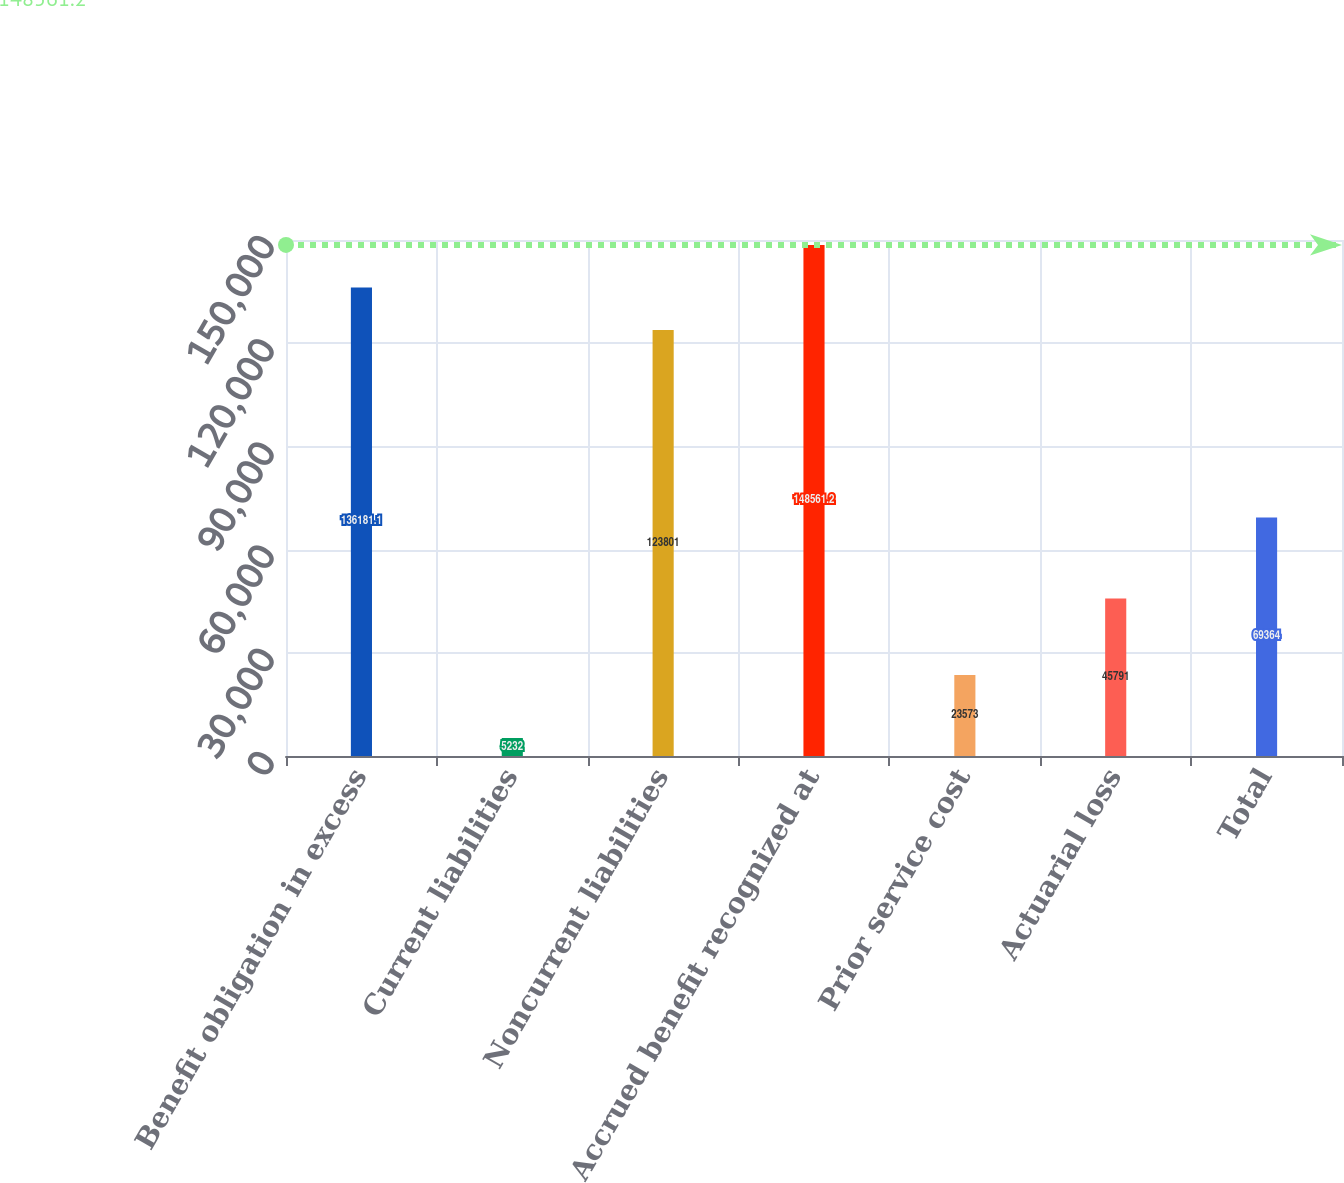Convert chart. <chart><loc_0><loc_0><loc_500><loc_500><bar_chart><fcel>Benefit obligation in excess<fcel>Current liabilities<fcel>Noncurrent liabilities<fcel>Accrued benefit recognized at<fcel>Prior service cost<fcel>Actuarial loss<fcel>Total<nl><fcel>136181<fcel>5232<fcel>123801<fcel>148561<fcel>23573<fcel>45791<fcel>69364<nl></chart> 